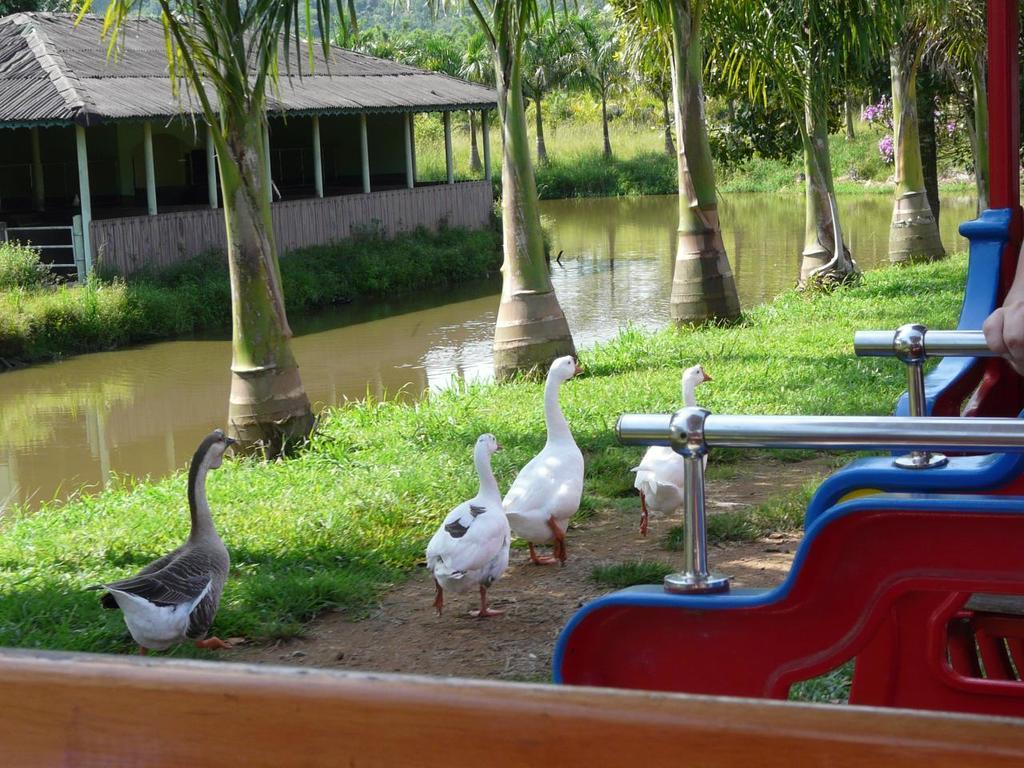What animals are in the middle of the image? There are three white ducks in the middle of the image. What are the ducks doing in the image? The ducks are walking. Can you describe the duck on the left side of the image? There is another duck on the left side of the image, walking on the grass. What can be seen in the background of the image? There is water visible in the image. What structure is on the left side of the image? There is a hut on the left side of the image. How many wings can be seen on the sheep in the image? There are no sheep present in the image, so there are no wings to count. 